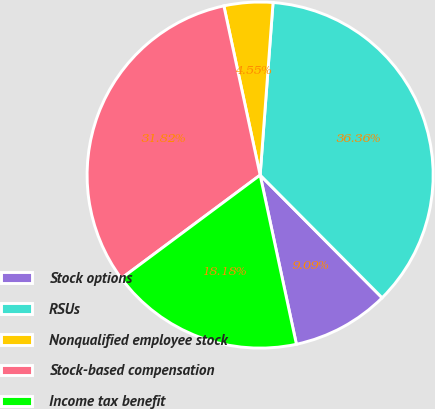Convert chart to OTSL. <chart><loc_0><loc_0><loc_500><loc_500><pie_chart><fcel>Stock options<fcel>RSUs<fcel>Nonqualified employee stock<fcel>Stock-based compensation<fcel>Income tax benefit<nl><fcel>9.09%<fcel>36.36%<fcel>4.55%<fcel>31.82%<fcel>18.18%<nl></chart> 